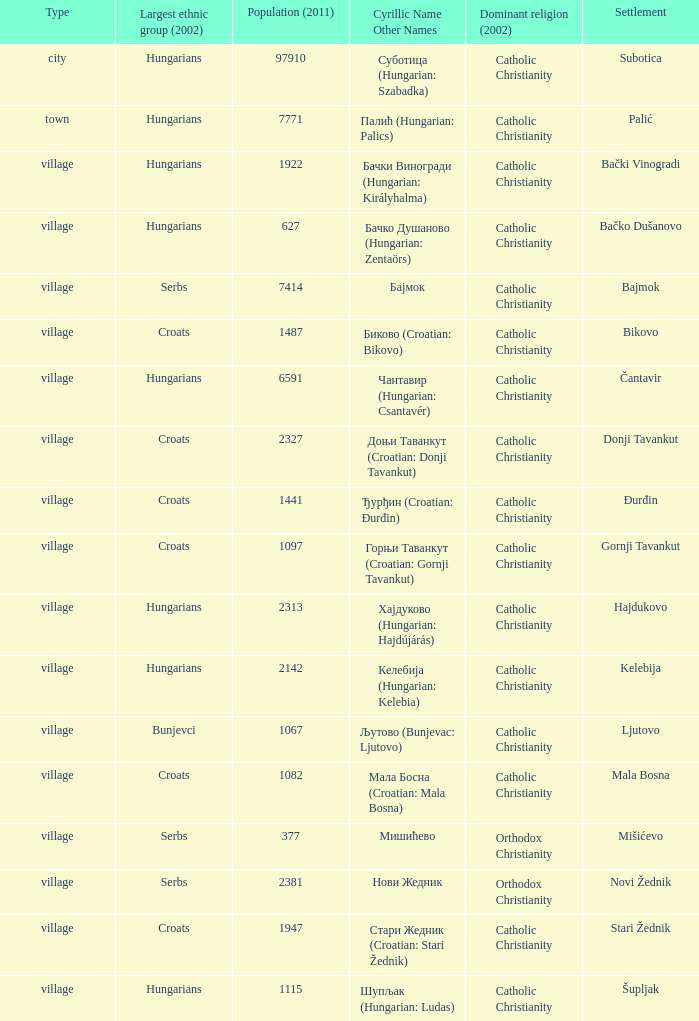What type of settlement has a population of 1441? Village. 